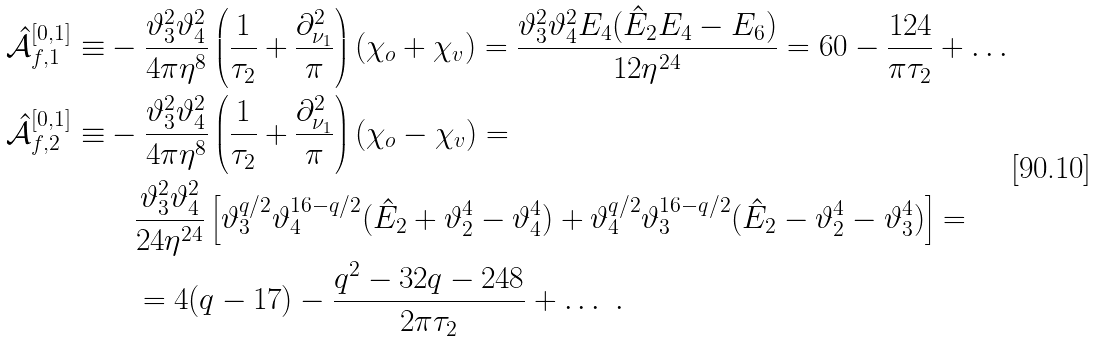Convert formula to latex. <formula><loc_0><loc_0><loc_500><loc_500>\hat { \mathcal { A } } _ { f , 1 } ^ { [ 0 , 1 ] } \equiv & - \frac { \vartheta _ { 3 } ^ { 2 } \vartheta _ { 4 } ^ { 2 } } { 4 \pi \eta ^ { 8 } } \left ( \frac { 1 } { \tau _ { 2 } } + \frac { \partial ^ { 2 } _ { \nu _ { 1 } } } { \pi } \right ) ( \chi _ { o } + \chi _ { v } ) = \frac { \vartheta _ { 3 } ^ { 2 } \vartheta _ { 4 } ^ { 2 } E _ { 4 } ( \hat { E } _ { 2 } E _ { 4 } - E _ { 6 } ) } { 1 2 \eta ^ { 2 4 } } = 6 0 - \frac { 1 2 4 } { \pi \tau _ { 2 } } + \dots \\ \hat { \mathcal { A } } _ { f , 2 } ^ { [ 0 , 1 ] } \equiv & - \frac { \vartheta _ { 3 } ^ { 2 } \vartheta _ { 4 } ^ { 2 } } { 4 \pi \eta ^ { 8 } } \left ( \frac { 1 } { \tau _ { 2 } } + \frac { \partial ^ { 2 } _ { \nu _ { 1 } } } { \pi } \right ) ( \chi _ { o } - \chi _ { v } ) = \\ & \quad \frac { \vartheta _ { 3 } ^ { 2 } \vartheta _ { 4 } ^ { 2 } } { 2 4 \eta ^ { 2 4 } } \left [ \vartheta _ { 3 } ^ { q / 2 } \vartheta _ { 4 } ^ { 1 6 - q / 2 } ( \hat { E } _ { 2 } + \vartheta _ { 2 } ^ { 4 } - \vartheta _ { 4 } ^ { 4 } ) + \vartheta _ { 4 } ^ { q / 2 } \vartheta _ { 3 } ^ { 1 6 - q / 2 } ( \hat { E } _ { 2 } - \vartheta _ { 2 } ^ { 4 } - \vartheta _ { 3 } ^ { 4 } ) \right ] = \\ & \quad = 4 ( q - 1 7 ) - \frac { q ^ { 2 } - 3 2 q - 2 4 8 } { 2 \pi \tau _ { 2 } } + \dots \ .</formula> 